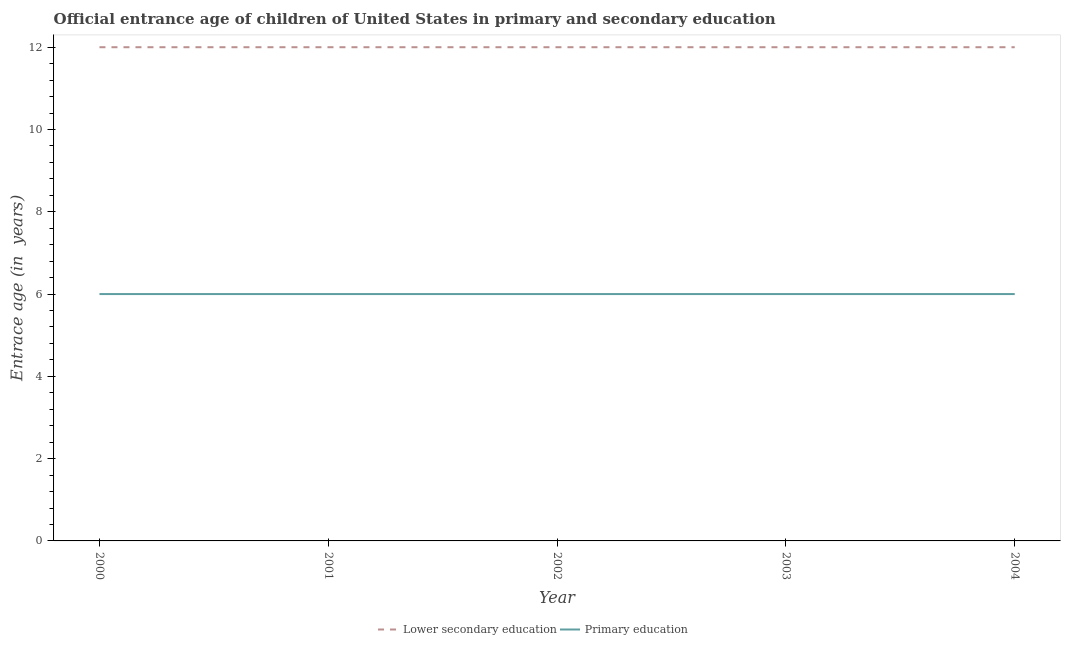Is the number of lines equal to the number of legend labels?
Provide a succinct answer. Yes. Across all years, what is the maximum entrance age of chiildren in primary education?
Your response must be concise. 6. In which year was the entrance age of children in lower secondary education maximum?
Offer a terse response. 2000. What is the total entrance age of children in lower secondary education in the graph?
Keep it short and to the point. 60. What is the difference between the entrance age of chiildren in primary education in 2002 and that in 2004?
Make the answer very short. 0. What is the average entrance age of chiildren in primary education per year?
Give a very brief answer. 6. In the year 2003, what is the difference between the entrance age of children in lower secondary education and entrance age of chiildren in primary education?
Offer a very short reply. 6. In how many years, is the entrance age of chiildren in primary education greater than 2.8 years?
Give a very brief answer. 5. What is the ratio of the entrance age of chiildren in primary education in 2001 to that in 2003?
Offer a terse response. 1. What is the difference between the highest and the second highest entrance age of chiildren in primary education?
Ensure brevity in your answer.  0. Is the sum of the entrance age of children in lower secondary education in 2001 and 2003 greater than the maximum entrance age of chiildren in primary education across all years?
Keep it short and to the point. Yes. Does the entrance age of chiildren in primary education monotonically increase over the years?
Your answer should be very brief. No. How many years are there in the graph?
Your response must be concise. 5. What is the difference between two consecutive major ticks on the Y-axis?
Offer a very short reply. 2. Does the graph contain grids?
Offer a very short reply. No. How are the legend labels stacked?
Give a very brief answer. Horizontal. What is the title of the graph?
Make the answer very short. Official entrance age of children of United States in primary and secondary education. Does "Taxes on profits and capital gains" appear as one of the legend labels in the graph?
Ensure brevity in your answer.  No. What is the label or title of the Y-axis?
Ensure brevity in your answer.  Entrace age (in  years). What is the Entrace age (in  years) in Lower secondary education in 2000?
Offer a very short reply. 12. What is the Entrace age (in  years) in Primary education in 2002?
Offer a terse response. 6. What is the Entrace age (in  years) of Lower secondary education in 2003?
Your answer should be very brief. 12. What is the Entrace age (in  years) in Primary education in 2003?
Ensure brevity in your answer.  6. What is the Entrace age (in  years) of Primary education in 2004?
Provide a succinct answer. 6. Across all years, what is the maximum Entrace age (in  years) of Lower secondary education?
Keep it short and to the point. 12. Across all years, what is the maximum Entrace age (in  years) of Primary education?
Give a very brief answer. 6. What is the total Entrace age (in  years) of Primary education in the graph?
Provide a short and direct response. 30. What is the difference between the Entrace age (in  years) of Lower secondary education in 2000 and that in 2001?
Keep it short and to the point. 0. What is the difference between the Entrace age (in  years) of Primary education in 2000 and that in 2001?
Your response must be concise. 0. What is the difference between the Entrace age (in  years) of Primary education in 2000 and that in 2002?
Provide a short and direct response. 0. What is the difference between the Entrace age (in  years) in Lower secondary education in 2000 and that in 2003?
Your response must be concise. 0. What is the difference between the Entrace age (in  years) in Lower secondary education in 2000 and that in 2004?
Provide a succinct answer. 0. What is the difference between the Entrace age (in  years) of Lower secondary education in 2001 and that in 2002?
Make the answer very short. 0. What is the difference between the Entrace age (in  years) of Lower secondary education in 2001 and that in 2004?
Make the answer very short. 0. What is the difference between the Entrace age (in  years) in Primary education in 2001 and that in 2004?
Your response must be concise. 0. What is the difference between the Entrace age (in  years) in Lower secondary education in 2002 and that in 2003?
Ensure brevity in your answer.  0. What is the difference between the Entrace age (in  years) in Primary education in 2002 and that in 2003?
Ensure brevity in your answer.  0. What is the difference between the Entrace age (in  years) in Lower secondary education in 2002 and that in 2004?
Keep it short and to the point. 0. What is the difference between the Entrace age (in  years) in Lower secondary education in 2003 and that in 2004?
Give a very brief answer. 0. What is the difference between the Entrace age (in  years) in Primary education in 2003 and that in 2004?
Keep it short and to the point. 0. What is the difference between the Entrace age (in  years) in Lower secondary education in 2000 and the Entrace age (in  years) in Primary education in 2001?
Your answer should be very brief. 6. What is the difference between the Entrace age (in  years) of Lower secondary education in 2000 and the Entrace age (in  years) of Primary education in 2002?
Ensure brevity in your answer.  6. What is the difference between the Entrace age (in  years) of Lower secondary education in 2000 and the Entrace age (in  years) of Primary education in 2003?
Provide a short and direct response. 6. What is the difference between the Entrace age (in  years) of Lower secondary education in 2001 and the Entrace age (in  years) of Primary education in 2002?
Provide a short and direct response. 6. What is the difference between the Entrace age (in  years) of Lower secondary education in 2001 and the Entrace age (in  years) of Primary education in 2003?
Make the answer very short. 6. What is the difference between the Entrace age (in  years) in Lower secondary education in 2001 and the Entrace age (in  years) in Primary education in 2004?
Provide a short and direct response. 6. What is the difference between the Entrace age (in  years) of Lower secondary education in 2002 and the Entrace age (in  years) of Primary education in 2003?
Your answer should be very brief. 6. What is the difference between the Entrace age (in  years) of Lower secondary education in 2002 and the Entrace age (in  years) of Primary education in 2004?
Your answer should be very brief. 6. What is the average Entrace age (in  years) in Lower secondary education per year?
Offer a very short reply. 12. In the year 2000, what is the difference between the Entrace age (in  years) in Lower secondary education and Entrace age (in  years) in Primary education?
Provide a short and direct response. 6. In the year 2001, what is the difference between the Entrace age (in  years) of Lower secondary education and Entrace age (in  years) of Primary education?
Make the answer very short. 6. In the year 2004, what is the difference between the Entrace age (in  years) of Lower secondary education and Entrace age (in  years) of Primary education?
Keep it short and to the point. 6. What is the ratio of the Entrace age (in  years) in Lower secondary education in 2000 to that in 2001?
Ensure brevity in your answer.  1. What is the ratio of the Entrace age (in  years) in Primary education in 2000 to that in 2003?
Your answer should be compact. 1. What is the ratio of the Entrace age (in  years) in Lower secondary education in 2001 to that in 2002?
Your answer should be very brief. 1. What is the ratio of the Entrace age (in  years) in Lower secondary education in 2001 to that in 2004?
Make the answer very short. 1. What is the ratio of the Entrace age (in  years) of Primary education in 2001 to that in 2004?
Make the answer very short. 1. What is the ratio of the Entrace age (in  years) of Lower secondary education in 2002 to that in 2004?
Your answer should be compact. 1. What is the ratio of the Entrace age (in  years) in Lower secondary education in 2003 to that in 2004?
Provide a short and direct response. 1. What is the ratio of the Entrace age (in  years) of Primary education in 2003 to that in 2004?
Your answer should be compact. 1. What is the difference between the highest and the second highest Entrace age (in  years) in Lower secondary education?
Provide a succinct answer. 0. What is the difference between the highest and the second highest Entrace age (in  years) in Primary education?
Keep it short and to the point. 0. What is the difference between the highest and the lowest Entrace age (in  years) of Lower secondary education?
Your response must be concise. 0. What is the difference between the highest and the lowest Entrace age (in  years) of Primary education?
Offer a very short reply. 0. 